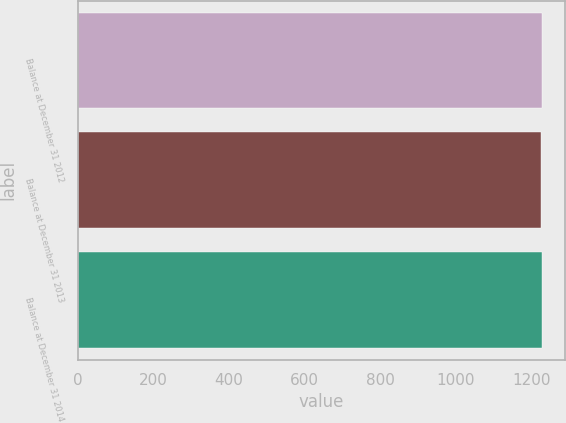<chart> <loc_0><loc_0><loc_500><loc_500><bar_chart><fcel>Balance at December 31 2012<fcel>Balance at December 31 2013<fcel>Balance at December 31 2014<nl><fcel>1228<fcel>1227<fcel>1227.1<nl></chart> 